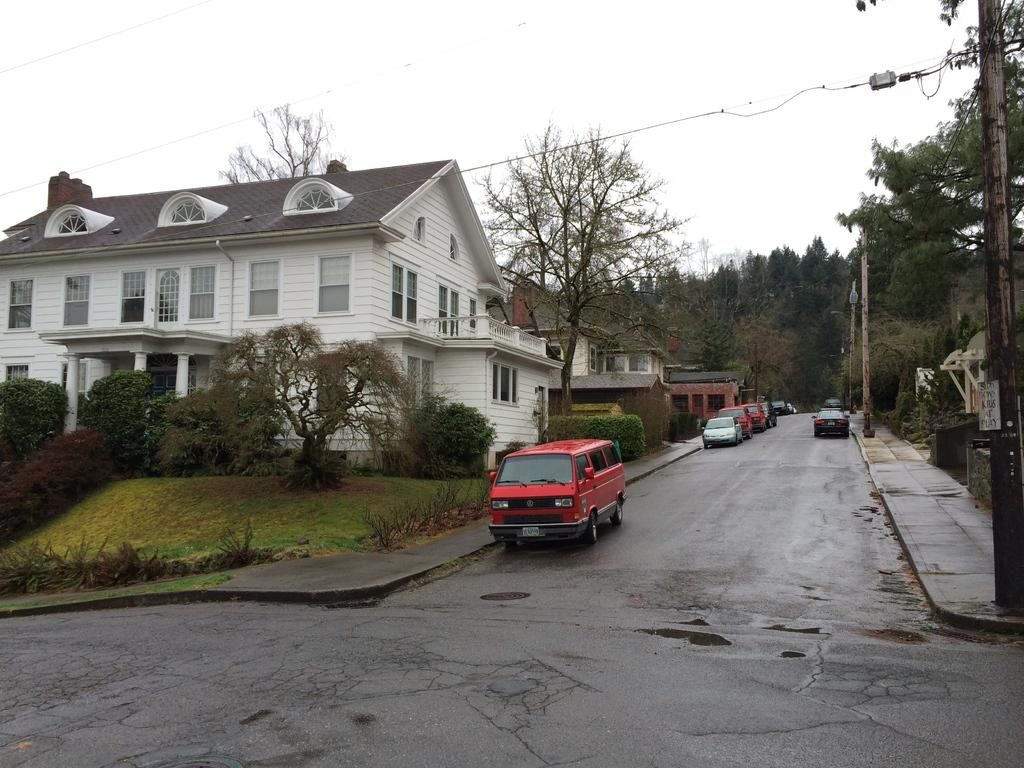What type of vehicles can be seen in the image? There are cars parked in the image. What structures are present in the image? There are buildings in the image. What type of vegetation is visible in the image? There are trees in the image. What other objects can be seen in the image? There are poles in the image. What is the condition of the sky in the image? The sky is cloudy in the image. Who is the minister cooking a meal in the image? There is no minister or cooking activity present in the image. What type of fiction is being read by the person in the image? There is no person reading fiction in the image. 